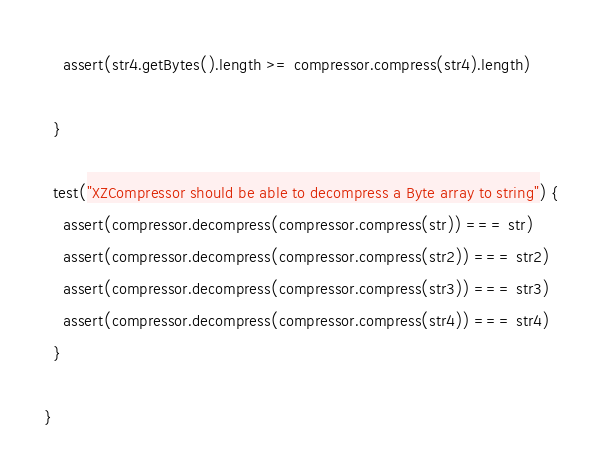<code> <loc_0><loc_0><loc_500><loc_500><_Scala_>    assert(str4.getBytes().length >= compressor.compress(str4).length)

  }

  test("XZCompressor should be able to decompress a Byte array to string") {
    assert(compressor.decompress(compressor.compress(str)) === str)
    assert(compressor.decompress(compressor.compress(str2)) === str2)
    assert(compressor.decompress(compressor.compress(str3)) === str3)
    assert(compressor.decompress(compressor.compress(str4)) === str4)
  }

}
</code> 